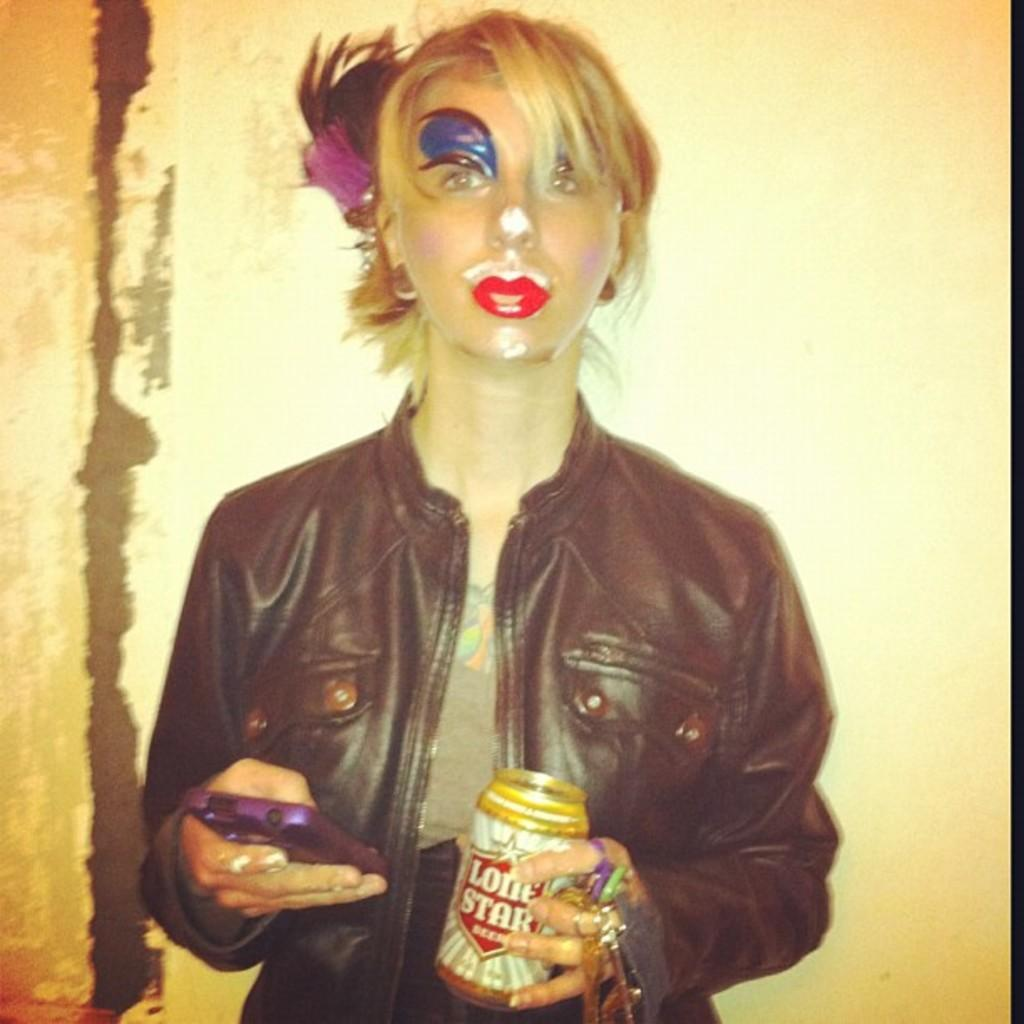What is the primary subject of the image? There is a woman in the image. What is the woman doing in the image? The woman is standing in the image. What objects is the woman holding in the image? The woman is holding a mobile phone and a jar in the image. What is the woman wearing in the image? The woman is wearing a black jacket in the image. What is covering the woman's face in the image? The woman has a costume covering her face in the image. How many brothers does the woman have in the image? There is no information about the woman's brothers in the image. What type of tree can be seen in the background of the image? There is no tree visible in the image. 